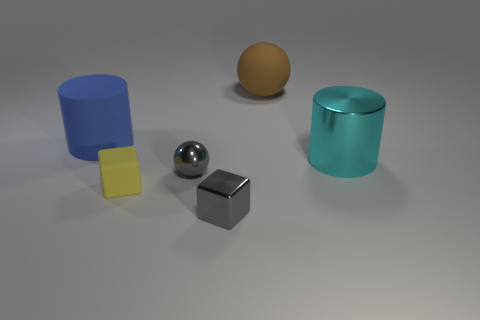There is a tiny sphere; is it the same color as the shiny object that is in front of the tiny gray metal ball?
Provide a succinct answer. Yes. The large matte thing that is to the right of the matte cylinder has what shape?
Your response must be concise. Sphere. What number of other objects are the same material as the small yellow object?
Keep it short and to the point. 2. What is the brown ball made of?
Keep it short and to the point. Rubber. What number of big things are either gray shiny spheres or cylinders?
Your answer should be compact. 2. There is a large blue cylinder; what number of large cyan things are to the left of it?
Your answer should be very brief. 0. Are there any rubber cubes of the same color as the tiny matte object?
Provide a short and direct response. No. What shape is the rubber thing that is the same size as the gray shiny sphere?
Make the answer very short. Cube. How many blue things are large metal things or spheres?
Provide a short and direct response. 0. How many other brown balls are the same size as the shiny ball?
Your response must be concise. 0. 